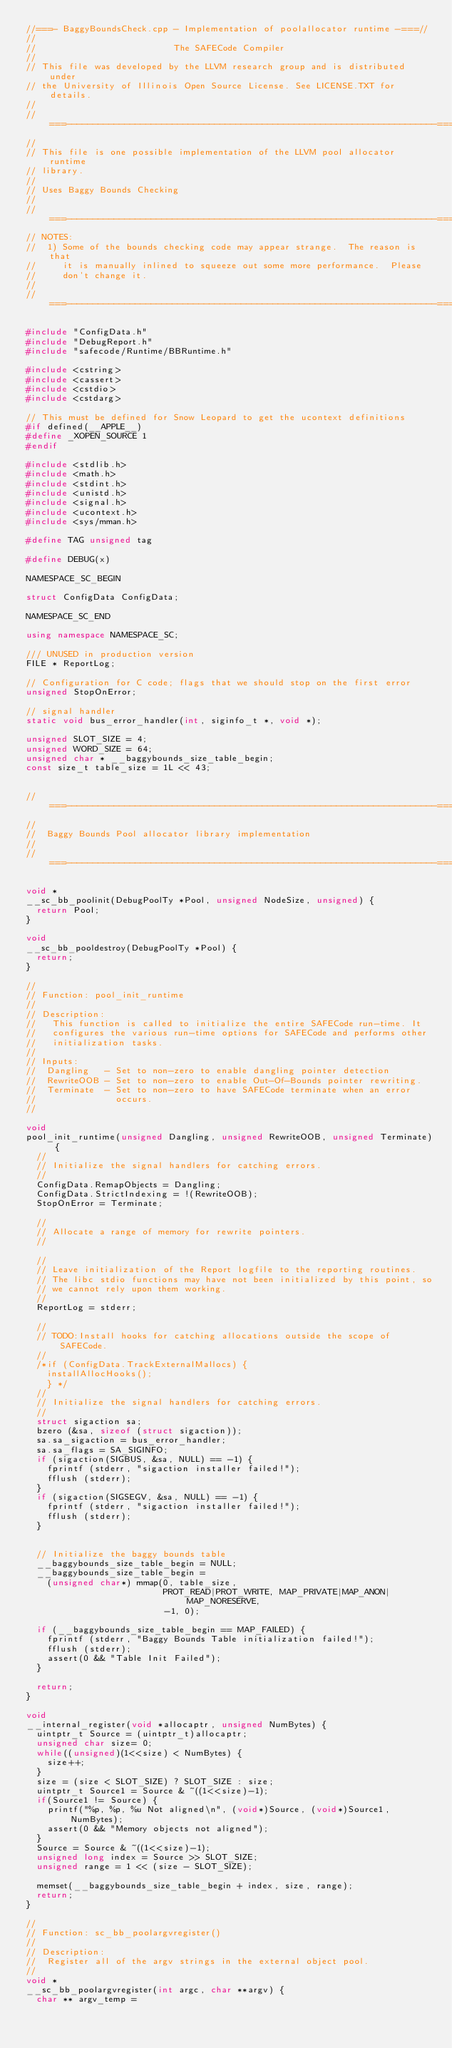Convert code to text. <code><loc_0><loc_0><loc_500><loc_500><_C++_>//===- BaggyBoundsCheck.cpp - Implementation of poolallocator runtime -===//
//
//                          The SAFECode Compiler
//
// This file was developed by the LLVM research group and is distributed under
// the University of Illinois Open Source License. See LICENSE.TXT for details.
//
//===----------------------------------------------------------------------===//
//
// This file is one possible implementation of the LLVM pool allocator runtime
// library.
//
// Uses Baggy Bounds Checking 
//
//===----------------------------------------------------------------------===//
// NOTES:
//  1) Some of the bounds checking code may appear strange.  The reason is that
//     it is manually inlined to squeeze out some more performance.  Please
//     don't change it.
//
//===----------------------------------------------------------------------===//

#include "ConfigData.h"
#include "DebugReport.h"
#include "safecode/Runtime/BBRuntime.h"

#include <cstring>
#include <cassert>
#include <cstdio>
#include <cstdarg>

// This must be defined for Snow Leopard to get the ucontext definitions
#if defined(__APPLE__)
#define _XOPEN_SOURCE 1
#endif

#include <stdlib.h>
#include <math.h>
#include <stdint.h>
#include <unistd.h>
#include <signal.h>
#include <ucontext.h>
#include <sys/mman.h>

#define TAG unsigned tag

#define DEBUG(x)

NAMESPACE_SC_BEGIN

struct ConfigData ConfigData;

NAMESPACE_SC_END

using namespace NAMESPACE_SC;

/// UNUSED in production version
FILE * ReportLog;

// Configuration for C code; flags that we should stop on the first error
unsigned StopOnError;

// signal handler
static void bus_error_handler(int, siginfo_t *, void *);

unsigned SLOT_SIZE = 4;
unsigned WORD_SIZE = 64;
unsigned char * __baggybounds_size_table_begin; 
const size_t table_size = 1L << 43;


//===----------------------------------------------------------------------===//
//
//  Baggy Bounds Pool allocator library implementation
//
//===----------------------------------------------------------------------===//

void *
__sc_bb_poolinit(DebugPoolTy *Pool, unsigned NodeSize, unsigned) {
  return Pool;
}

void 
__sc_bb_pooldestroy(DebugPoolTy *Pool) {
  return;
}

//
// Function: pool_init_runtime
//
// Description: 
//   This function is called to initialize the entire SAFECode run-time. It 
//   configures the various run-time options for SAFECode and performs other
//   initialization tasks.
//
// Inputs:
//  Dangling   - Set to non-zero to enable dangling pointer detection
//  RewriteOOB - Set to non-zero to enable Out-Of-Bounds pointer rewriting.
//  Terminate  - Set to non-zero to have SAFECode terminate when an error 
//               occurs. 
//

void 
pool_init_runtime(unsigned Dangling, unsigned RewriteOOB, unsigned Terminate) {
  //
  // Initialize the signal handlers for catching errors.
  //
  ConfigData.RemapObjects = Dangling;
  ConfigData.StrictIndexing = !(RewriteOOB);
  StopOnError = Terminate;

  //
  // Allocate a range of memory for rewrite pointers.
  //

  //
  // Leave initialization of the Report logfile to the reporting routines.
  // The libc stdio functions may have not been initialized by this point, so
  // we cannot rely upon them working.
  //
  ReportLog = stderr;

  //
  // TODO:Install hooks for catching allocations outside the scope of SAFECode.
  //
  /*if (ConfigData.TrackExternalMallocs) {
    installAllocHooks();
    } */ 
  //
  // Initialize the signal handlers for catching errors.
  //
  struct sigaction sa;
  bzero (&sa, sizeof (struct sigaction));
  sa.sa_sigaction = bus_error_handler;
  sa.sa_flags = SA_SIGINFO;
  if (sigaction(SIGBUS, &sa, NULL) == -1) {
    fprintf (stderr, "sigaction installer failed!");
    fflush (stderr);
  }
  if (sigaction(SIGSEGV, &sa, NULL) == -1) {
    fprintf (stderr, "sigaction installer failed!");
    fflush (stderr);
  }


  // Initialize the baggy bounds table
  __baggybounds_size_table_begin = NULL;
  __baggybounds_size_table_begin = 
    (unsigned char*) mmap(0, table_size, 
                          PROT_READ|PROT_WRITE, MAP_PRIVATE|MAP_ANON|MAP_NORESERVE, 
                          -1, 0);

  if (__baggybounds_size_table_begin == MAP_FAILED) {
    fprintf (stderr, "Baggy Bounds Table initialization failed!");
    fflush (stderr);
    assert(0 && "Table Init Failed");
  }

  return;
}

void
__internal_register(void *allocaptr, unsigned NumBytes) {
  uintptr_t Source = (uintptr_t)allocaptr;
  unsigned char size= 0;
  while((unsigned)(1<<size) < NumBytes) {
    size++;
  }
  size = (size < SLOT_SIZE) ? SLOT_SIZE : size;
  uintptr_t Source1 = Source & ~((1<<size)-1);
  if(Source1 != Source) {
    printf("%p, %p, %u Not aligned\n", (void*)Source, (void*)Source1, NumBytes);
    assert(0 && "Memory objects not aligned");
  }
  Source = Source & ~((1<<size)-1);
  unsigned long index = Source >> SLOT_SIZE;
  unsigned range = 1 << (size - SLOT_SIZE);

  memset(__baggybounds_size_table_begin + index, size, range);
  return;
}

//
// Function: sc_bb_poolargvregister()
//
// Description:
//  Register all of the argv strings in the external object pool.
//
void * 
__sc_bb_poolargvregister(int argc, char **argv) {
  char ** argv_temp = </code> 